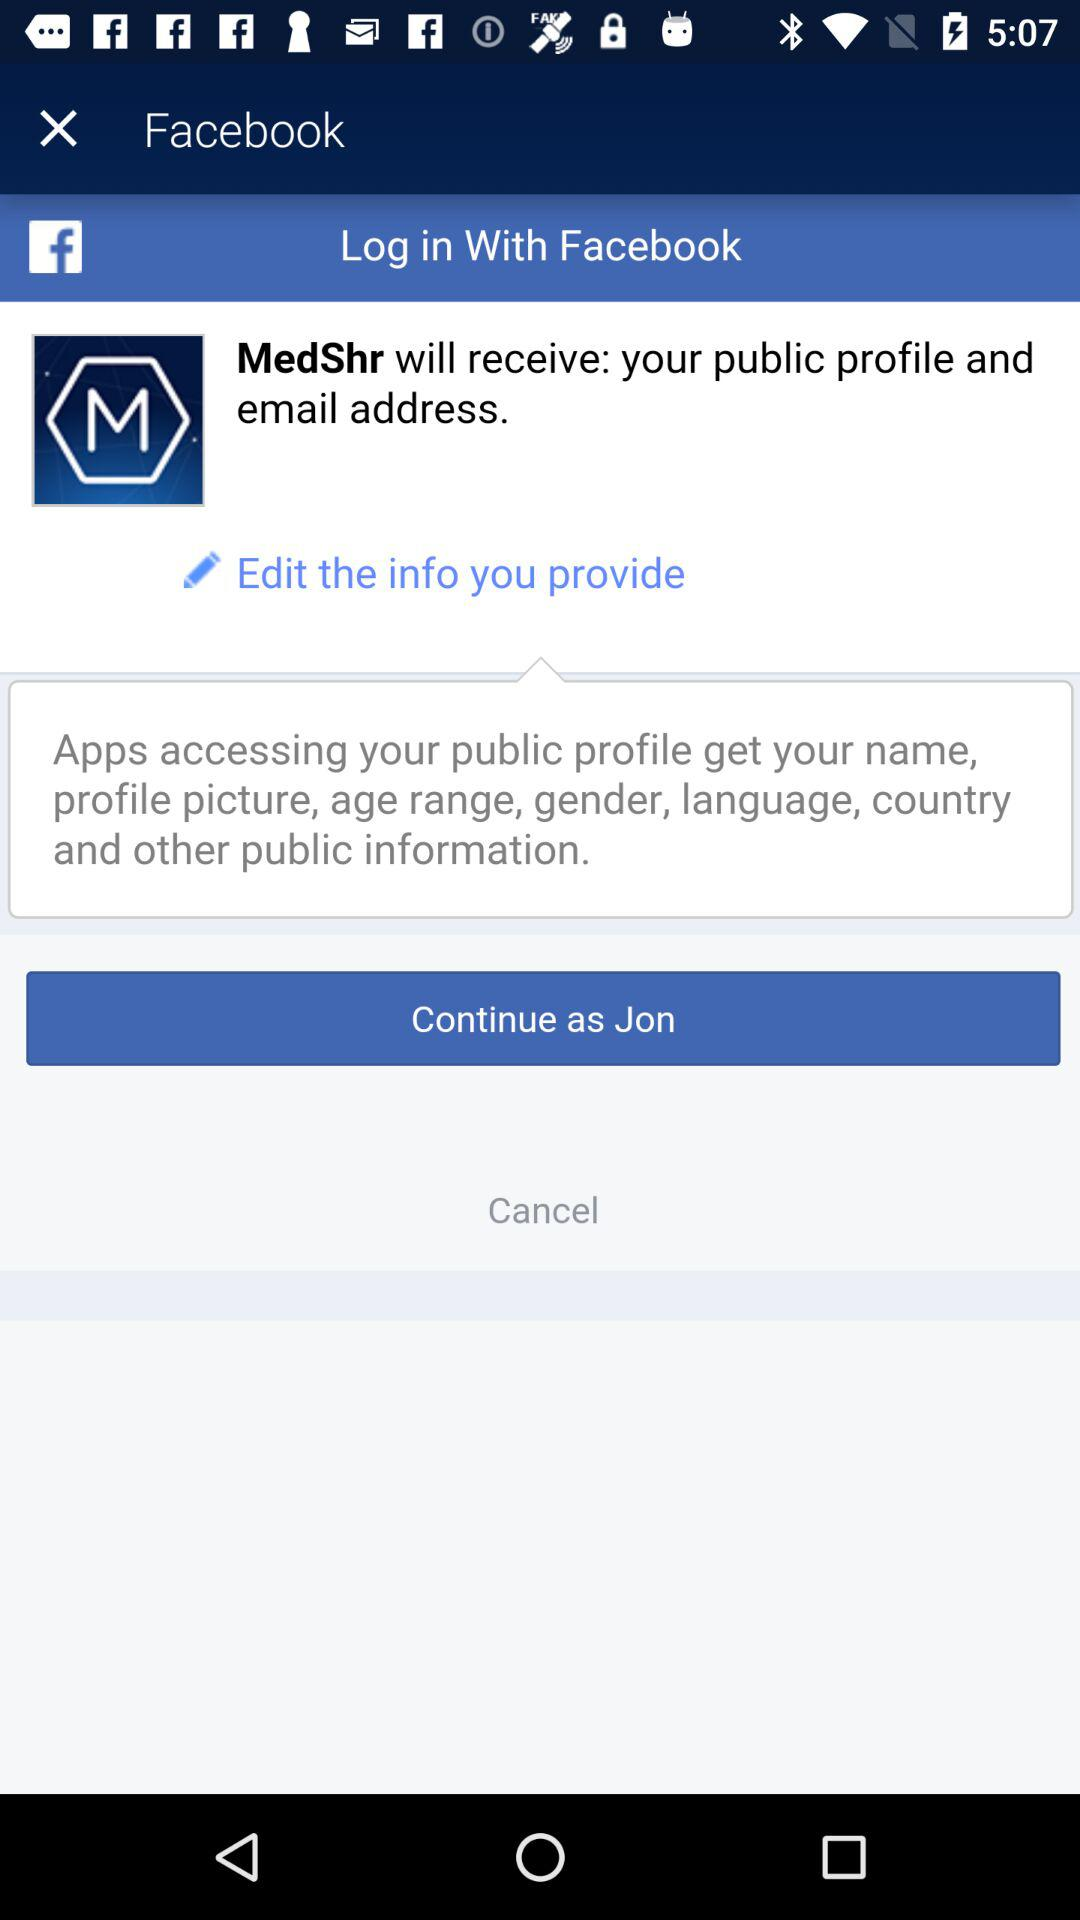By what user name can the application continue to perform? The user name is Jon. 